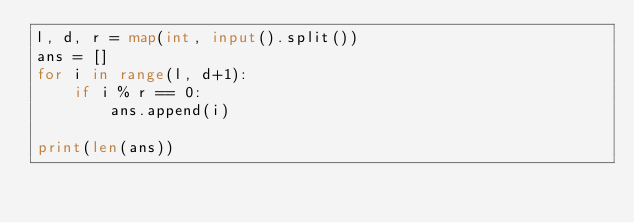Convert code to text. <code><loc_0><loc_0><loc_500><loc_500><_Python_>l, d, r = map(int, input().split())
ans = []
for i in range(l, d+1):
    if i % r == 0:
        ans.append(i)

print(len(ans))
</code> 